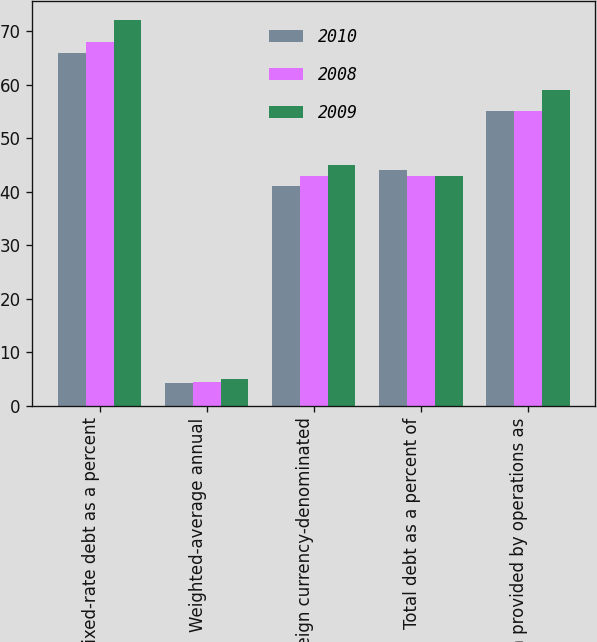Convert chart to OTSL. <chart><loc_0><loc_0><loc_500><loc_500><stacked_bar_chart><ecel><fcel>Fixed-rate debt as a percent<fcel>Weighted-average annual<fcel>Foreign currency-denominated<fcel>Total debt as a percent of<fcel>Cash provided by operations as<nl><fcel>2010<fcel>66<fcel>4.3<fcel>41<fcel>44<fcel>55<nl><fcel>2008<fcel>68<fcel>4.5<fcel>43<fcel>43<fcel>55<nl><fcel>2009<fcel>72<fcel>5<fcel>45<fcel>43<fcel>59<nl></chart> 